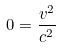<formula> <loc_0><loc_0><loc_500><loc_500>0 = \frac { v ^ { 2 } } { c ^ { 2 } }</formula> 